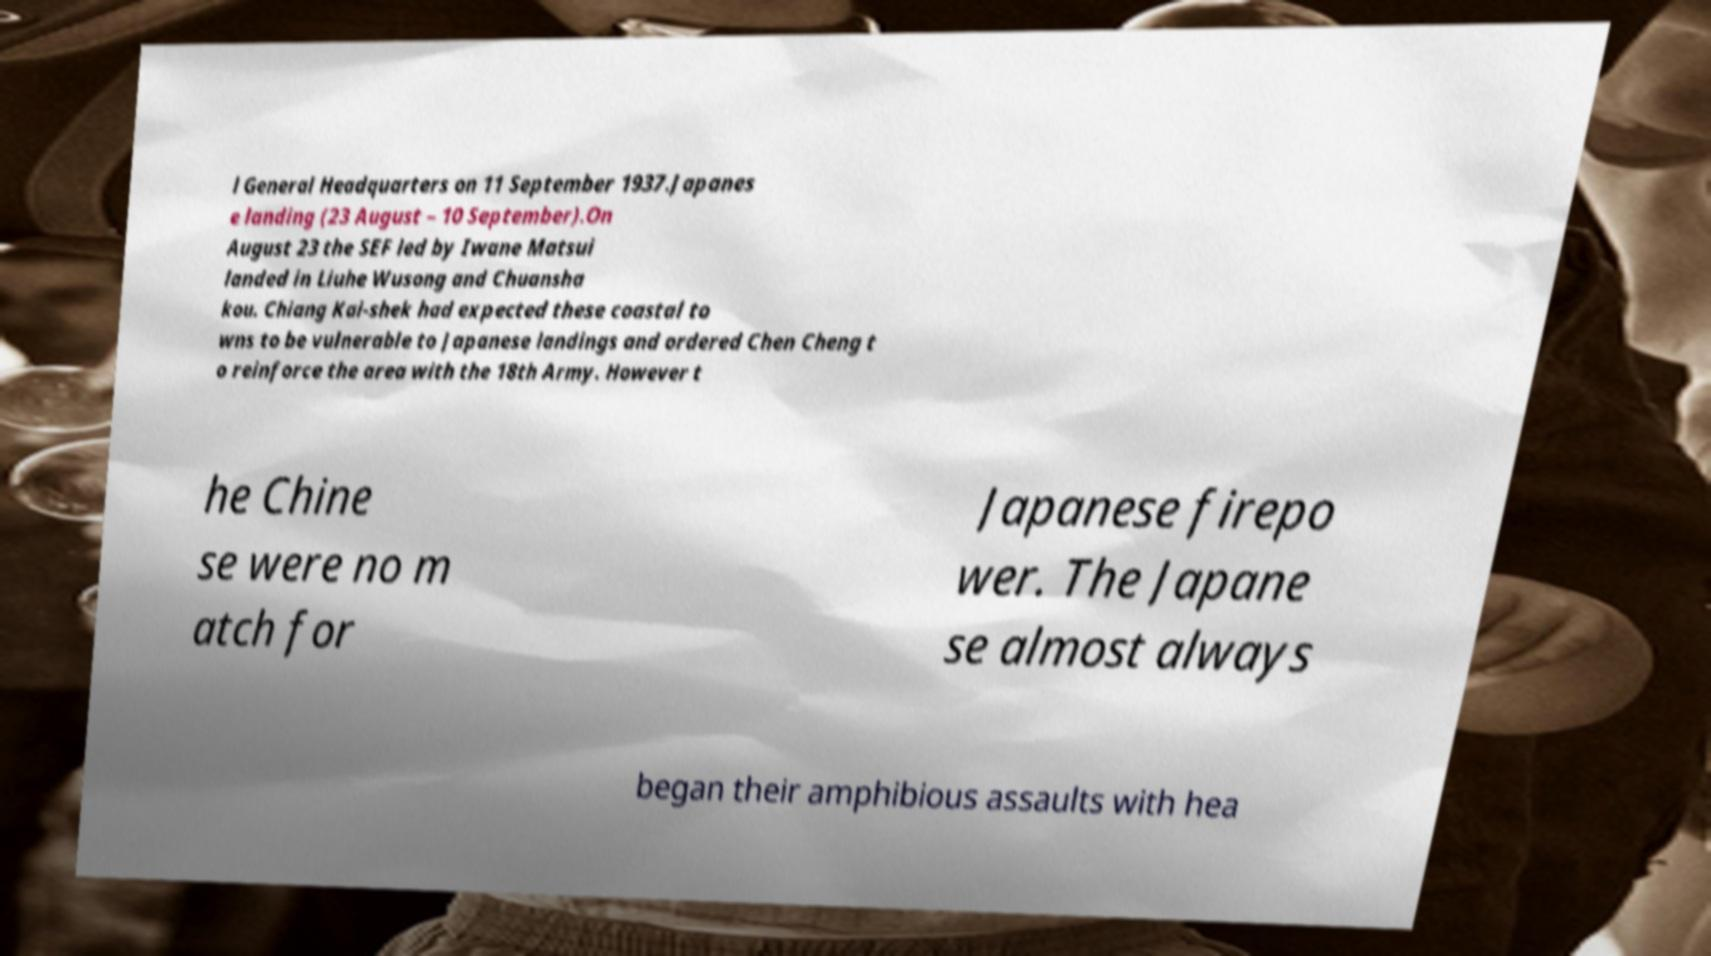Can you accurately transcribe the text from the provided image for me? l General Headquarters on 11 September 1937.Japanes e landing (23 August – 10 September).On August 23 the SEF led by Iwane Matsui landed in Liuhe Wusong and Chuansha kou. Chiang Kai-shek had expected these coastal to wns to be vulnerable to Japanese landings and ordered Chen Cheng t o reinforce the area with the 18th Army. However t he Chine se were no m atch for Japanese firepo wer. The Japane se almost always began their amphibious assaults with hea 